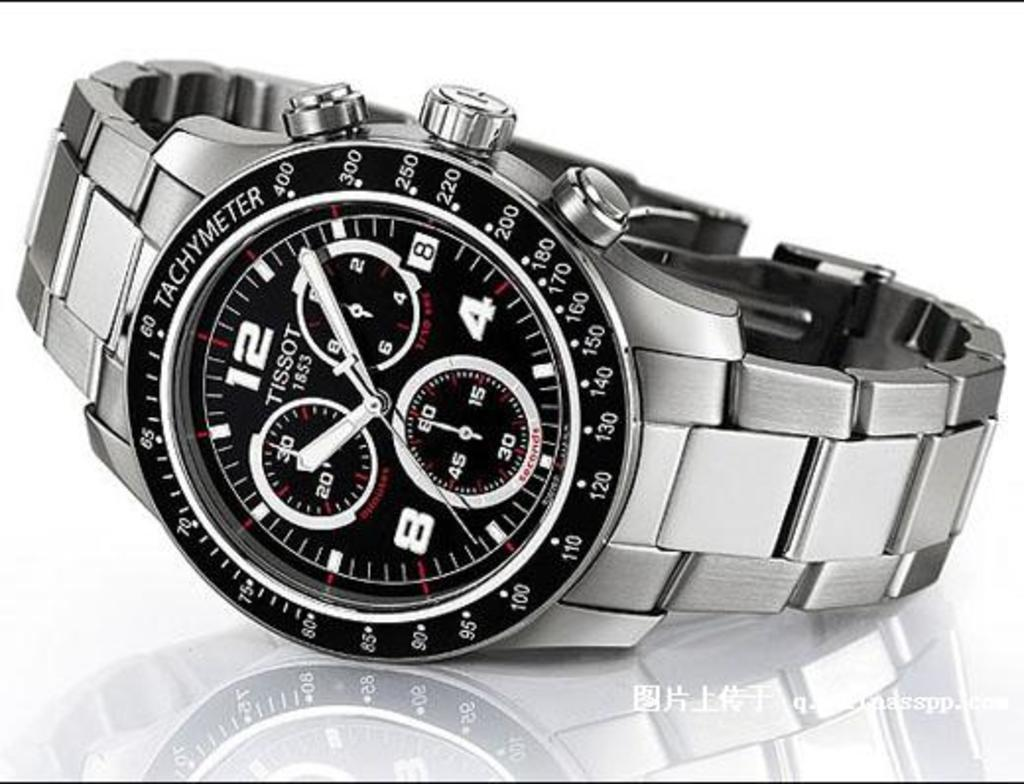<image>
Write a terse but informative summary of the picture. Black and silver watch which has the name TISSOT on the face. 